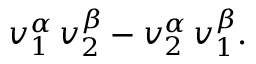<formula> <loc_0><loc_0><loc_500><loc_500>v _ { 1 } ^ { \alpha } \, v _ { 2 } ^ { \beta } - v _ { 2 } ^ { \alpha } \, v _ { 1 } ^ { \beta } .</formula> 